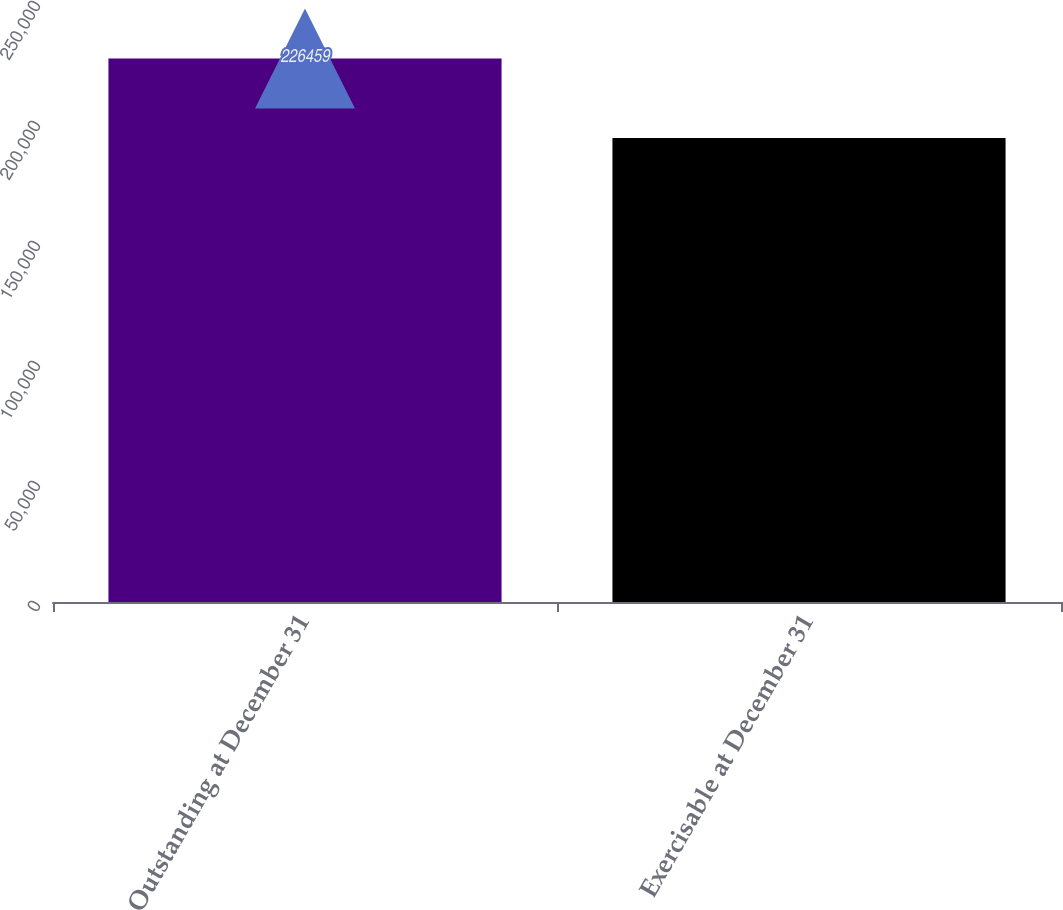Convert chart to OTSL. <chart><loc_0><loc_0><loc_500><loc_500><bar_chart><fcel>Outstanding at December 31<fcel>Exercisable at December 31<nl><fcel>226459<fcel>193339<nl></chart> 